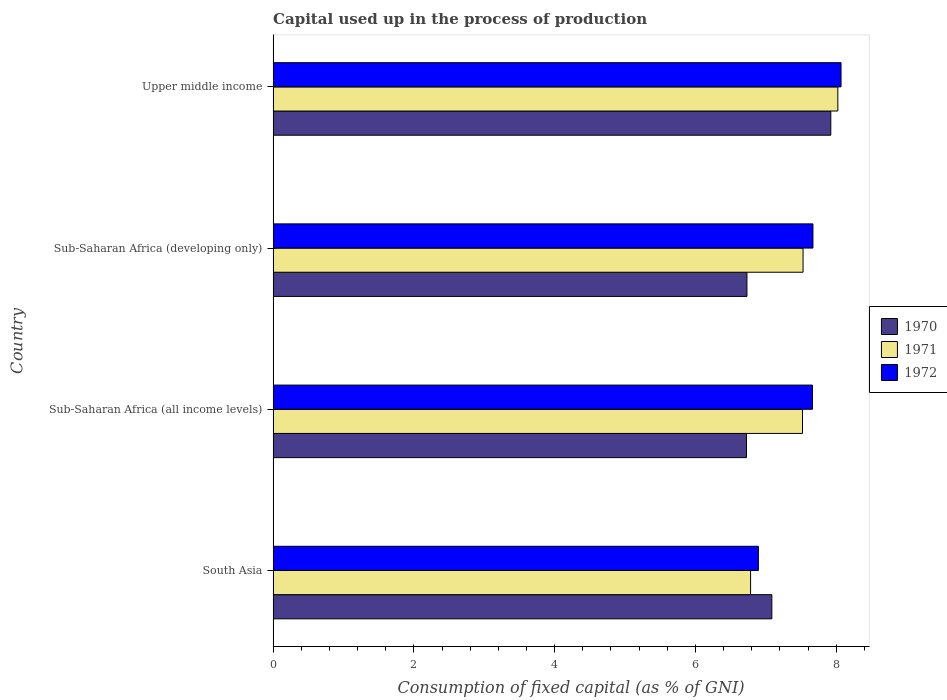How many different coloured bars are there?
Offer a very short reply. 3. Are the number of bars on each tick of the Y-axis equal?
Provide a succinct answer. Yes. How many bars are there on the 2nd tick from the top?
Give a very brief answer. 3. What is the label of the 4th group of bars from the top?
Offer a very short reply. South Asia. In how many cases, is the number of bars for a given country not equal to the number of legend labels?
Your answer should be very brief. 0. What is the capital used up in the process of production in 1971 in South Asia?
Offer a terse response. 6.78. Across all countries, what is the maximum capital used up in the process of production in 1971?
Your response must be concise. 8.02. Across all countries, what is the minimum capital used up in the process of production in 1971?
Make the answer very short. 6.78. In which country was the capital used up in the process of production in 1971 maximum?
Your response must be concise. Upper middle income. In which country was the capital used up in the process of production in 1970 minimum?
Provide a succinct answer. Sub-Saharan Africa (all income levels). What is the total capital used up in the process of production in 1970 in the graph?
Give a very brief answer. 28.46. What is the difference between the capital used up in the process of production in 1971 in South Asia and that in Upper middle income?
Offer a very short reply. -1.24. What is the difference between the capital used up in the process of production in 1970 in Sub-Saharan Africa (developing only) and the capital used up in the process of production in 1971 in South Asia?
Your answer should be very brief. -0.05. What is the average capital used up in the process of production in 1971 per country?
Your response must be concise. 7.46. What is the difference between the capital used up in the process of production in 1970 and capital used up in the process of production in 1971 in South Asia?
Your response must be concise. 0.3. What is the ratio of the capital used up in the process of production in 1970 in South Asia to that in Upper middle income?
Your answer should be very brief. 0.89. Is the capital used up in the process of production in 1972 in South Asia less than that in Sub-Saharan Africa (all income levels)?
Your answer should be compact. Yes. What is the difference between the highest and the second highest capital used up in the process of production in 1971?
Provide a short and direct response. 0.49. What is the difference between the highest and the lowest capital used up in the process of production in 1972?
Offer a terse response. 1.17. In how many countries, is the capital used up in the process of production in 1972 greater than the average capital used up in the process of production in 1972 taken over all countries?
Provide a short and direct response. 3. Is the sum of the capital used up in the process of production in 1972 in Sub-Saharan Africa (all income levels) and Upper middle income greater than the maximum capital used up in the process of production in 1970 across all countries?
Provide a short and direct response. Yes. What does the 3rd bar from the bottom in Sub-Saharan Africa (developing only) represents?
Provide a succinct answer. 1972. Is it the case that in every country, the sum of the capital used up in the process of production in 1972 and capital used up in the process of production in 1971 is greater than the capital used up in the process of production in 1970?
Your answer should be very brief. Yes. Does the graph contain grids?
Your answer should be compact. No. How many legend labels are there?
Provide a short and direct response. 3. How are the legend labels stacked?
Keep it short and to the point. Vertical. What is the title of the graph?
Offer a very short reply. Capital used up in the process of production. Does "1972" appear as one of the legend labels in the graph?
Your answer should be compact. Yes. What is the label or title of the X-axis?
Provide a short and direct response. Consumption of fixed capital (as % of GNI). What is the label or title of the Y-axis?
Offer a terse response. Country. What is the Consumption of fixed capital (as % of GNI) of 1970 in South Asia?
Offer a very short reply. 7.09. What is the Consumption of fixed capital (as % of GNI) of 1971 in South Asia?
Ensure brevity in your answer.  6.78. What is the Consumption of fixed capital (as % of GNI) in 1972 in South Asia?
Keep it short and to the point. 6.89. What is the Consumption of fixed capital (as % of GNI) of 1970 in Sub-Saharan Africa (all income levels)?
Provide a succinct answer. 6.72. What is the Consumption of fixed capital (as % of GNI) in 1971 in Sub-Saharan Africa (all income levels)?
Ensure brevity in your answer.  7.52. What is the Consumption of fixed capital (as % of GNI) of 1972 in Sub-Saharan Africa (all income levels)?
Your answer should be compact. 7.66. What is the Consumption of fixed capital (as % of GNI) in 1970 in Sub-Saharan Africa (developing only)?
Provide a succinct answer. 6.73. What is the Consumption of fixed capital (as % of GNI) in 1971 in Sub-Saharan Africa (developing only)?
Your response must be concise. 7.53. What is the Consumption of fixed capital (as % of GNI) of 1972 in Sub-Saharan Africa (developing only)?
Offer a very short reply. 7.67. What is the Consumption of fixed capital (as % of GNI) of 1970 in Upper middle income?
Your answer should be very brief. 7.92. What is the Consumption of fixed capital (as % of GNI) in 1971 in Upper middle income?
Provide a succinct answer. 8.02. What is the Consumption of fixed capital (as % of GNI) in 1972 in Upper middle income?
Provide a succinct answer. 8.07. Across all countries, what is the maximum Consumption of fixed capital (as % of GNI) in 1970?
Offer a terse response. 7.92. Across all countries, what is the maximum Consumption of fixed capital (as % of GNI) in 1971?
Give a very brief answer. 8.02. Across all countries, what is the maximum Consumption of fixed capital (as % of GNI) in 1972?
Your response must be concise. 8.07. Across all countries, what is the minimum Consumption of fixed capital (as % of GNI) in 1970?
Ensure brevity in your answer.  6.72. Across all countries, what is the minimum Consumption of fixed capital (as % of GNI) in 1971?
Your response must be concise. 6.78. Across all countries, what is the minimum Consumption of fixed capital (as % of GNI) in 1972?
Your answer should be compact. 6.89. What is the total Consumption of fixed capital (as % of GNI) in 1970 in the graph?
Provide a succinct answer. 28.46. What is the total Consumption of fixed capital (as % of GNI) in 1971 in the graph?
Make the answer very short. 29.86. What is the total Consumption of fixed capital (as % of GNI) in 1972 in the graph?
Offer a terse response. 30.29. What is the difference between the Consumption of fixed capital (as % of GNI) in 1970 in South Asia and that in Sub-Saharan Africa (all income levels)?
Keep it short and to the point. 0.36. What is the difference between the Consumption of fixed capital (as % of GNI) of 1971 in South Asia and that in Sub-Saharan Africa (all income levels)?
Ensure brevity in your answer.  -0.74. What is the difference between the Consumption of fixed capital (as % of GNI) in 1972 in South Asia and that in Sub-Saharan Africa (all income levels)?
Offer a terse response. -0.77. What is the difference between the Consumption of fixed capital (as % of GNI) in 1970 in South Asia and that in Sub-Saharan Africa (developing only)?
Your answer should be very brief. 0.35. What is the difference between the Consumption of fixed capital (as % of GNI) in 1971 in South Asia and that in Sub-Saharan Africa (developing only)?
Keep it short and to the point. -0.75. What is the difference between the Consumption of fixed capital (as % of GNI) in 1972 in South Asia and that in Sub-Saharan Africa (developing only)?
Offer a terse response. -0.77. What is the difference between the Consumption of fixed capital (as % of GNI) of 1970 in South Asia and that in Upper middle income?
Ensure brevity in your answer.  -0.84. What is the difference between the Consumption of fixed capital (as % of GNI) of 1971 in South Asia and that in Upper middle income?
Your answer should be compact. -1.24. What is the difference between the Consumption of fixed capital (as % of GNI) in 1972 in South Asia and that in Upper middle income?
Keep it short and to the point. -1.17. What is the difference between the Consumption of fixed capital (as % of GNI) of 1970 in Sub-Saharan Africa (all income levels) and that in Sub-Saharan Africa (developing only)?
Make the answer very short. -0.01. What is the difference between the Consumption of fixed capital (as % of GNI) in 1971 in Sub-Saharan Africa (all income levels) and that in Sub-Saharan Africa (developing only)?
Keep it short and to the point. -0.01. What is the difference between the Consumption of fixed capital (as % of GNI) in 1972 in Sub-Saharan Africa (all income levels) and that in Sub-Saharan Africa (developing only)?
Keep it short and to the point. -0.01. What is the difference between the Consumption of fixed capital (as % of GNI) of 1970 in Sub-Saharan Africa (all income levels) and that in Upper middle income?
Provide a succinct answer. -1.2. What is the difference between the Consumption of fixed capital (as % of GNI) in 1971 in Sub-Saharan Africa (all income levels) and that in Upper middle income?
Your answer should be compact. -0.5. What is the difference between the Consumption of fixed capital (as % of GNI) of 1972 in Sub-Saharan Africa (all income levels) and that in Upper middle income?
Your answer should be very brief. -0.41. What is the difference between the Consumption of fixed capital (as % of GNI) in 1970 in Sub-Saharan Africa (developing only) and that in Upper middle income?
Keep it short and to the point. -1.19. What is the difference between the Consumption of fixed capital (as % of GNI) in 1971 in Sub-Saharan Africa (developing only) and that in Upper middle income?
Your response must be concise. -0.49. What is the difference between the Consumption of fixed capital (as % of GNI) in 1972 in Sub-Saharan Africa (developing only) and that in Upper middle income?
Your answer should be compact. -0.4. What is the difference between the Consumption of fixed capital (as % of GNI) in 1970 in South Asia and the Consumption of fixed capital (as % of GNI) in 1971 in Sub-Saharan Africa (all income levels)?
Offer a very short reply. -0.44. What is the difference between the Consumption of fixed capital (as % of GNI) in 1970 in South Asia and the Consumption of fixed capital (as % of GNI) in 1972 in Sub-Saharan Africa (all income levels)?
Your answer should be compact. -0.58. What is the difference between the Consumption of fixed capital (as % of GNI) of 1971 in South Asia and the Consumption of fixed capital (as % of GNI) of 1972 in Sub-Saharan Africa (all income levels)?
Offer a terse response. -0.88. What is the difference between the Consumption of fixed capital (as % of GNI) in 1970 in South Asia and the Consumption of fixed capital (as % of GNI) in 1971 in Sub-Saharan Africa (developing only)?
Give a very brief answer. -0.44. What is the difference between the Consumption of fixed capital (as % of GNI) in 1970 in South Asia and the Consumption of fixed capital (as % of GNI) in 1972 in Sub-Saharan Africa (developing only)?
Your response must be concise. -0.58. What is the difference between the Consumption of fixed capital (as % of GNI) of 1971 in South Asia and the Consumption of fixed capital (as % of GNI) of 1972 in Sub-Saharan Africa (developing only)?
Keep it short and to the point. -0.89. What is the difference between the Consumption of fixed capital (as % of GNI) in 1970 in South Asia and the Consumption of fixed capital (as % of GNI) in 1971 in Upper middle income?
Offer a terse response. -0.94. What is the difference between the Consumption of fixed capital (as % of GNI) of 1970 in South Asia and the Consumption of fixed capital (as % of GNI) of 1972 in Upper middle income?
Offer a very short reply. -0.98. What is the difference between the Consumption of fixed capital (as % of GNI) of 1971 in South Asia and the Consumption of fixed capital (as % of GNI) of 1972 in Upper middle income?
Provide a succinct answer. -1.28. What is the difference between the Consumption of fixed capital (as % of GNI) in 1970 in Sub-Saharan Africa (all income levels) and the Consumption of fixed capital (as % of GNI) in 1971 in Sub-Saharan Africa (developing only)?
Provide a short and direct response. -0.8. What is the difference between the Consumption of fixed capital (as % of GNI) of 1970 in Sub-Saharan Africa (all income levels) and the Consumption of fixed capital (as % of GNI) of 1972 in Sub-Saharan Africa (developing only)?
Your response must be concise. -0.94. What is the difference between the Consumption of fixed capital (as % of GNI) of 1971 in Sub-Saharan Africa (all income levels) and the Consumption of fixed capital (as % of GNI) of 1972 in Sub-Saharan Africa (developing only)?
Offer a terse response. -0.15. What is the difference between the Consumption of fixed capital (as % of GNI) in 1970 in Sub-Saharan Africa (all income levels) and the Consumption of fixed capital (as % of GNI) in 1971 in Upper middle income?
Your answer should be very brief. -1.3. What is the difference between the Consumption of fixed capital (as % of GNI) in 1970 in Sub-Saharan Africa (all income levels) and the Consumption of fixed capital (as % of GNI) in 1972 in Upper middle income?
Ensure brevity in your answer.  -1.34. What is the difference between the Consumption of fixed capital (as % of GNI) of 1971 in Sub-Saharan Africa (all income levels) and the Consumption of fixed capital (as % of GNI) of 1972 in Upper middle income?
Your response must be concise. -0.55. What is the difference between the Consumption of fixed capital (as % of GNI) of 1970 in Sub-Saharan Africa (developing only) and the Consumption of fixed capital (as % of GNI) of 1971 in Upper middle income?
Your answer should be compact. -1.29. What is the difference between the Consumption of fixed capital (as % of GNI) of 1970 in Sub-Saharan Africa (developing only) and the Consumption of fixed capital (as % of GNI) of 1972 in Upper middle income?
Provide a succinct answer. -1.34. What is the difference between the Consumption of fixed capital (as % of GNI) in 1971 in Sub-Saharan Africa (developing only) and the Consumption of fixed capital (as % of GNI) in 1972 in Upper middle income?
Make the answer very short. -0.54. What is the average Consumption of fixed capital (as % of GNI) of 1970 per country?
Give a very brief answer. 7.12. What is the average Consumption of fixed capital (as % of GNI) in 1971 per country?
Your response must be concise. 7.46. What is the average Consumption of fixed capital (as % of GNI) of 1972 per country?
Offer a terse response. 7.57. What is the difference between the Consumption of fixed capital (as % of GNI) of 1970 and Consumption of fixed capital (as % of GNI) of 1971 in South Asia?
Keep it short and to the point. 0.3. What is the difference between the Consumption of fixed capital (as % of GNI) of 1970 and Consumption of fixed capital (as % of GNI) of 1972 in South Asia?
Ensure brevity in your answer.  0.19. What is the difference between the Consumption of fixed capital (as % of GNI) of 1971 and Consumption of fixed capital (as % of GNI) of 1972 in South Asia?
Provide a short and direct response. -0.11. What is the difference between the Consumption of fixed capital (as % of GNI) in 1970 and Consumption of fixed capital (as % of GNI) in 1971 in Sub-Saharan Africa (all income levels)?
Offer a very short reply. -0.8. What is the difference between the Consumption of fixed capital (as % of GNI) of 1970 and Consumption of fixed capital (as % of GNI) of 1972 in Sub-Saharan Africa (all income levels)?
Offer a very short reply. -0.94. What is the difference between the Consumption of fixed capital (as % of GNI) in 1971 and Consumption of fixed capital (as % of GNI) in 1972 in Sub-Saharan Africa (all income levels)?
Keep it short and to the point. -0.14. What is the difference between the Consumption of fixed capital (as % of GNI) of 1970 and Consumption of fixed capital (as % of GNI) of 1971 in Sub-Saharan Africa (developing only)?
Provide a short and direct response. -0.8. What is the difference between the Consumption of fixed capital (as % of GNI) of 1970 and Consumption of fixed capital (as % of GNI) of 1972 in Sub-Saharan Africa (developing only)?
Provide a succinct answer. -0.94. What is the difference between the Consumption of fixed capital (as % of GNI) of 1971 and Consumption of fixed capital (as % of GNI) of 1972 in Sub-Saharan Africa (developing only)?
Make the answer very short. -0.14. What is the difference between the Consumption of fixed capital (as % of GNI) of 1970 and Consumption of fixed capital (as % of GNI) of 1971 in Upper middle income?
Your answer should be very brief. -0.1. What is the difference between the Consumption of fixed capital (as % of GNI) in 1970 and Consumption of fixed capital (as % of GNI) in 1972 in Upper middle income?
Your answer should be very brief. -0.15. What is the difference between the Consumption of fixed capital (as % of GNI) of 1971 and Consumption of fixed capital (as % of GNI) of 1972 in Upper middle income?
Keep it short and to the point. -0.05. What is the ratio of the Consumption of fixed capital (as % of GNI) of 1970 in South Asia to that in Sub-Saharan Africa (all income levels)?
Give a very brief answer. 1.05. What is the ratio of the Consumption of fixed capital (as % of GNI) in 1971 in South Asia to that in Sub-Saharan Africa (all income levels)?
Provide a short and direct response. 0.9. What is the ratio of the Consumption of fixed capital (as % of GNI) in 1972 in South Asia to that in Sub-Saharan Africa (all income levels)?
Your answer should be compact. 0.9. What is the ratio of the Consumption of fixed capital (as % of GNI) of 1970 in South Asia to that in Sub-Saharan Africa (developing only)?
Make the answer very short. 1.05. What is the ratio of the Consumption of fixed capital (as % of GNI) of 1971 in South Asia to that in Sub-Saharan Africa (developing only)?
Offer a very short reply. 0.9. What is the ratio of the Consumption of fixed capital (as % of GNI) of 1972 in South Asia to that in Sub-Saharan Africa (developing only)?
Make the answer very short. 0.9. What is the ratio of the Consumption of fixed capital (as % of GNI) in 1970 in South Asia to that in Upper middle income?
Ensure brevity in your answer.  0.89. What is the ratio of the Consumption of fixed capital (as % of GNI) of 1971 in South Asia to that in Upper middle income?
Make the answer very short. 0.85. What is the ratio of the Consumption of fixed capital (as % of GNI) in 1972 in South Asia to that in Upper middle income?
Make the answer very short. 0.85. What is the ratio of the Consumption of fixed capital (as % of GNI) in 1972 in Sub-Saharan Africa (all income levels) to that in Sub-Saharan Africa (developing only)?
Offer a terse response. 1. What is the ratio of the Consumption of fixed capital (as % of GNI) of 1970 in Sub-Saharan Africa (all income levels) to that in Upper middle income?
Your answer should be very brief. 0.85. What is the ratio of the Consumption of fixed capital (as % of GNI) in 1972 in Sub-Saharan Africa (all income levels) to that in Upper middle income?
Offer a very short reply. 0.95. What is the ratio of the Consumption of fixed capital (as % of GNI) of 1970 in Sub-Saharan Africa (developing only) to that in Upper middle income?
Your answer should be compact. 0.85. What is the ratio of the Consumption of fixed capital (as % of GNI) of 1971 in Sub-Saharan Africa (developing only) to that in Upper middle income?
Your answer should be compact. 0.94. What is the ratio of the Consumption of fixed capital (as % of GNI) of 1972 in Sub-Saharan Africa (developing only) to that in Upper middle income?
Ensure brevity in your answer.  0.95. What is the difference between the highest and the second highest Consumption of fixed capital (as % of GNI) in 1970?
Provide a succinct answer. 0.84. What is the difference between the highest and the second highest Consumption of fixed capital (as % of GNI) of 1971?
Offer a terse response. 0.49. What is the difference between the highest and the second highest Consumption of fixed capital (as % of GNI) of 1972?
Provide a succinct answer. 0.4. What is the difference between the highest and the lowest Consumption of fixed capital (as % of GNI) of 1970?
Keep it short and to the point. 1.2. What is the difference between the highest and the lowest Consumption of fixed capital (as % of GNI) in 1971?
Give a very brief answer. 1.24. What is the difference between the highest and the lowest Consumption of fixed capital (as % of GNI) of 1972?
Give a very brief answer. 1.17. 